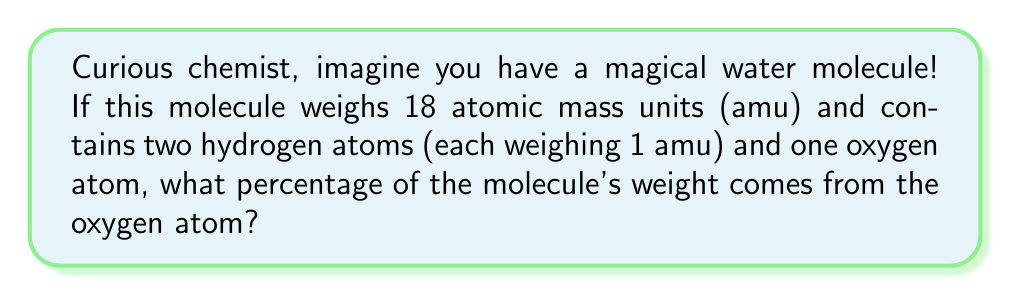Can you solve this math problem? Let's break this down step-by-step:

1) First, we need to find the weight of the oxygen atom:
   - Total weight of molecule = 18 amu
   - Weight of hydrogen atoms = 2 × 1 amu = 2 amu
   - Weight of oxygen atom = Total weight - Weight of hydrogen atoms
   $$ \text{Weight of oxygen} = 18 \text{ amu} - 2 \text{ amu} = 16 \text{ amu} $$

2) Now, to find the percentage, we use this formula:
   $$ \text{Percentage} = \frac{\text{Weight of oxygen}}{\text{Total weight of molecule}} \times 100\% $$

3) Let's plug in our numbers:
   $$ \text{Percentage} = \frac{16 \text{ amu}}{18 \text{ amu}} \times 100\% $$

4) Simplify the fraction:
   $$ \text{Percentage} = \frac{8}{9} \times 100\% $$

5) Calculate the final percentage:
   $$ \text{Percentage} = 88.89\% $$

So, the oxygen atom makes up about 88.89% of the water molecule's weight!
Answer: 88.89% 